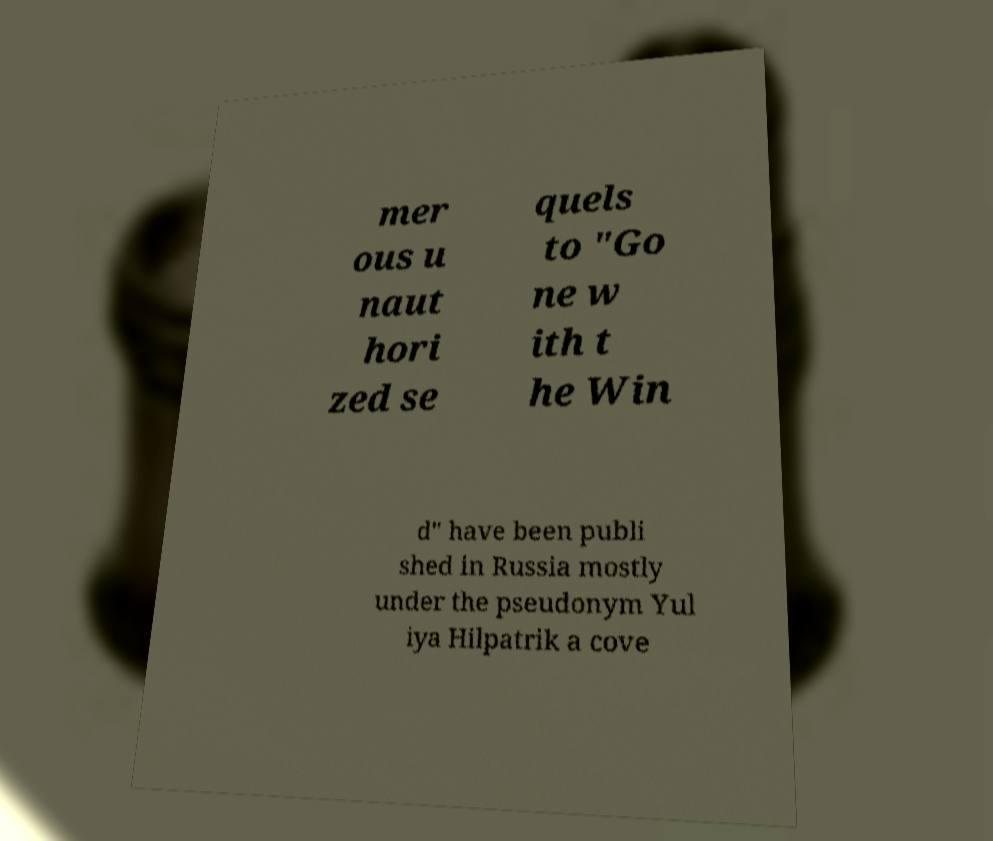Could you assist in decoding the text presented in this image and type it out clearly? mer ous u naut hori zed se quels to "Go ne w ith t he Win d" have been publi shed in Russia mostly under the pseudonym Yul iya Hilpatrik a cove 